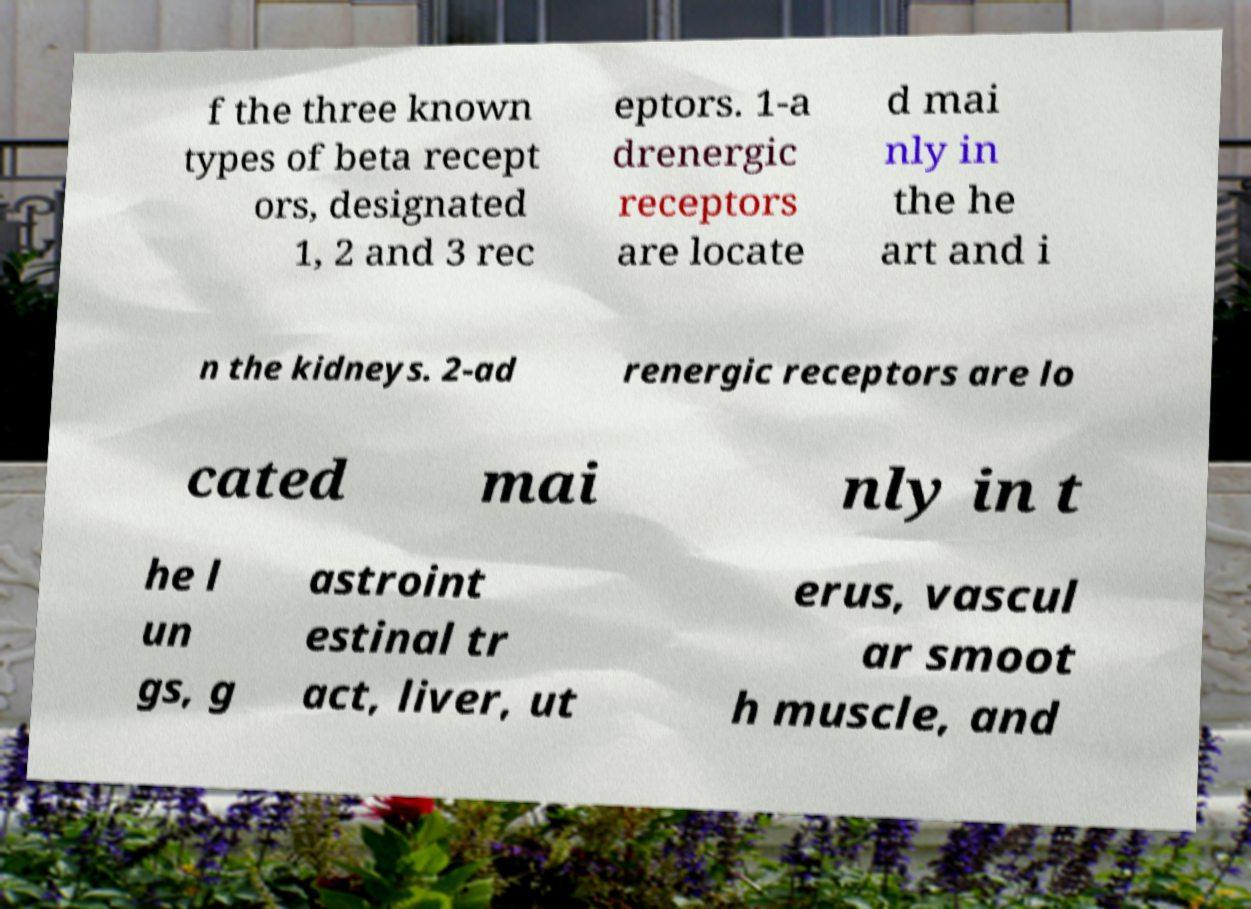I need the written content from this picture converted into text. Can you do that? f the three known types of beta recept ors, designated 1, 2 and 3 rec eptors. 1-a drenergic receptors are locate d mai nly in the he art and i n the kidneys. 2-ad renergic receptors are lo cated mai nly in t he l un gs, g astroint estinal tr act, liver, ut erus, vascul ar smoot h muscle, and 